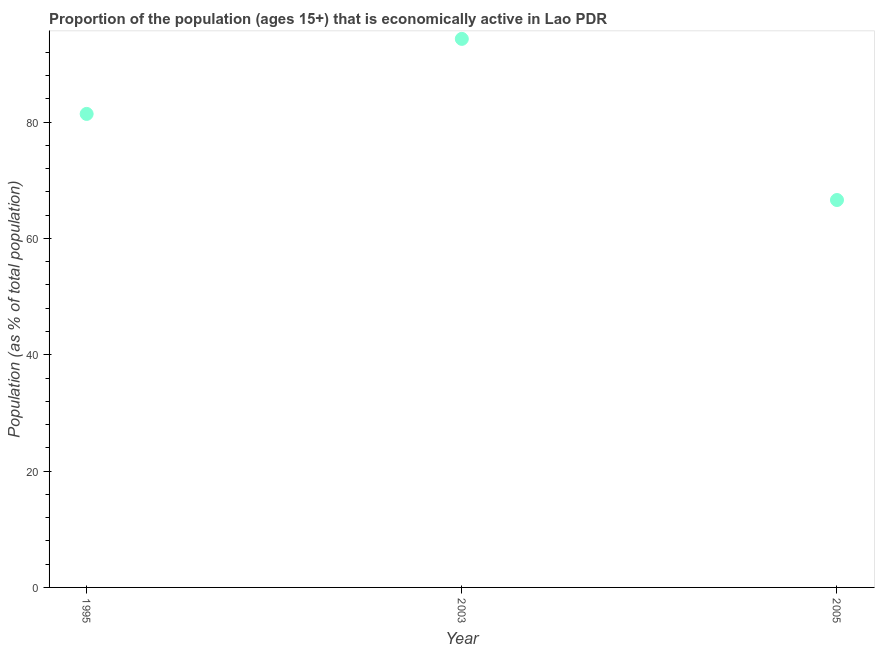What is the percentage of economically active population in 1995?
Your answer should be very brief. 81.4. Across all years, what is the maximum percentage of economically active population?
Your answer should be compact. 94.3. Across all years, what is the minimum percentage of economically active population?
Make the answer very short. 66.6. In which year was the percentage of economically active population maximum?
Offer a terse response. 2003. What is the sum of the percentage of economically active population?
Offer a very short reply. 242.3. What is the difference between the percentage of economically active population in 1995 and 2003?
Provide a succinct answer. -12.9. What is the average percentage of economically active population per year?
Your answer should be compact. 80.77. What is the median percentage of economically active population?
Your response must be concise. 81.4. Do a majority of the years between 2003 and 1995 (inclusive) have percentage of economically active population greater than 24 %?
Your response must be concise. No. What is the ratio of the percentage of economically active population in 1995 to that in 2005?
Your answer should be compact. 1.22. Is the percentage of economically active population in 1995 less than that in 2005?
Provide a succinct answer. No. What is the difference between the highest and the second highest percentage of economically active population?
Make the answer very short. 12.9. Is the sum of the percentage of economically active population in 1995 and 2003 greater than the maximum percentage of economically active population across all years?
Offer a very short reply. Yes. What is the difference between the highest and the lowest percentage of economically active population?
Make the answer very short. 27.7. In how many years, is the percentage of economically active population greater than the average percentage of economically active population taken over all years?
Ensure brevity in your answer.  2. Are the values on the major ticks of Y-axis written in scientific E-notation?
Make the answer very short. No. Does the graph contain any zero values?
Provide a short and direct response. No. What is the title of the graph?
Your answer should be very brief. Proportion of the population (ages 15+) that is economically active in Lao PDR. What is the label or title of the Y-axis?
Provide a short and direct response. Population (as % of total population). What is the Population (as % of total population) in 1995?
Provide a succinct answer. 81.4. What is the Population (as % of total population) in 2003?
Ensure brevity in your answer.  94.3. What is the Population (as % of total population) in 2005?
Provide a succinct answer. 66.6. What is the difference between the Population (as % of total population) in 1995 and 2003?
Keep it short and to the point. -12.9. What is the difference between the Population (as % of total population) in 2003 and 2005?
Give a very brief answer. 27.7. What is the ratio of the Population (as % of total population) in 1995 to that in 2003?
Ensure brevity in your answer.  0.86. What is the ratio of the Population (as % of total population) in 1995 to that in 2005?
Keep it short and to the point. 1.22. What is the ratio of the Population (as % of total population) in 2003 to that in 2005?
Provide a short and direct response. 1.42. 